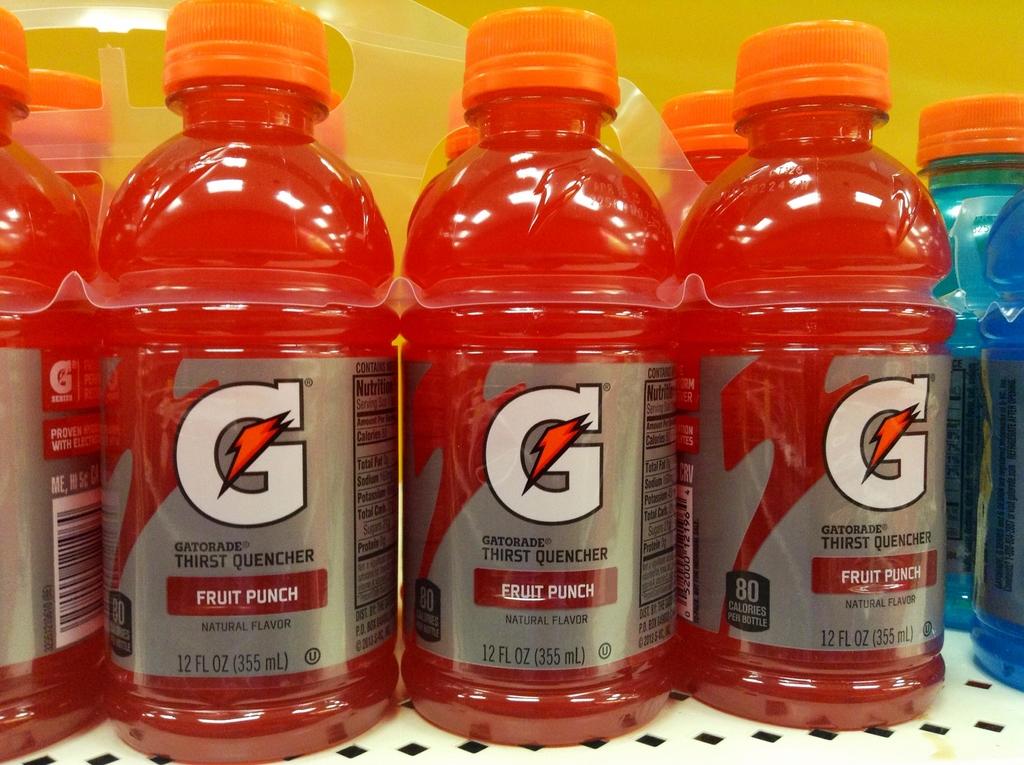What flavor is the red liquid in the bottle?
Provide a short and direct response. Fruit punch. How many ounces are in the bottle?
Give a very brief answer. 12. 